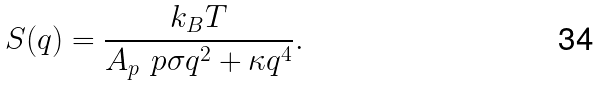<formula> <loc_0><loc_0><loc_500><loc_500>S ( q ) = \frac { k _ { B } T } { A _ { p } \ p { \sigma q ^ { 2 } + \kappa q ^ { 4 } } } .</formula> 